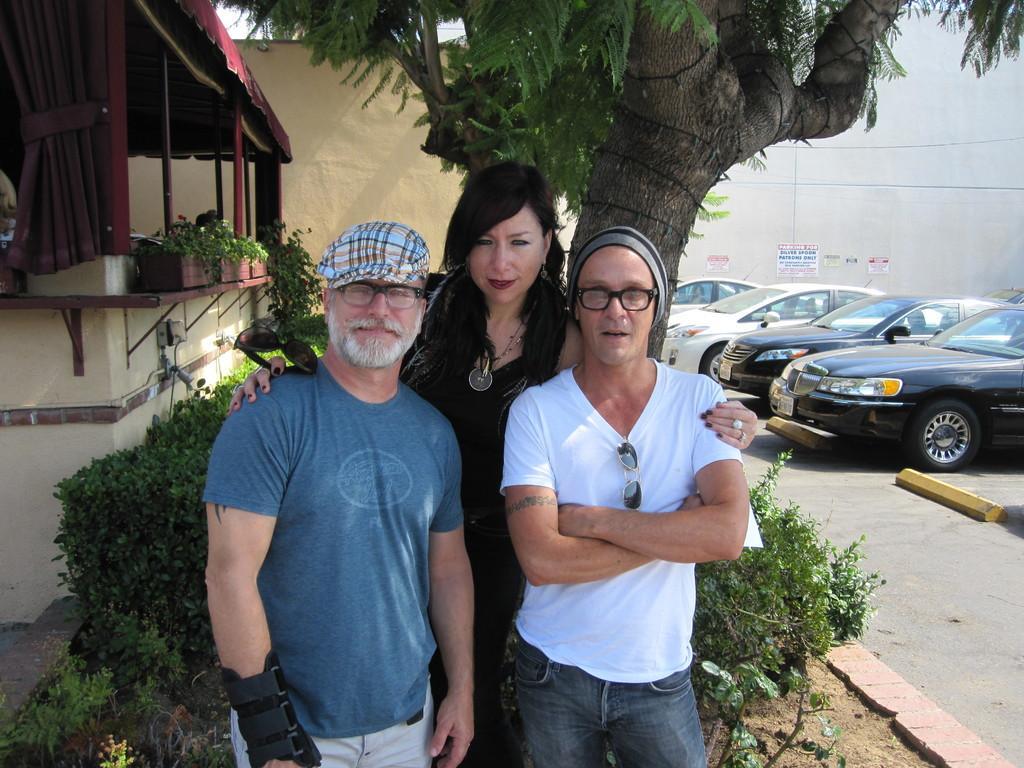Please provide a concise description of this image. In the image we can see there are people standing and there are men wearing caps. Behind there are cars parked on the road and there is a tree. There are plants kept in a pot. 